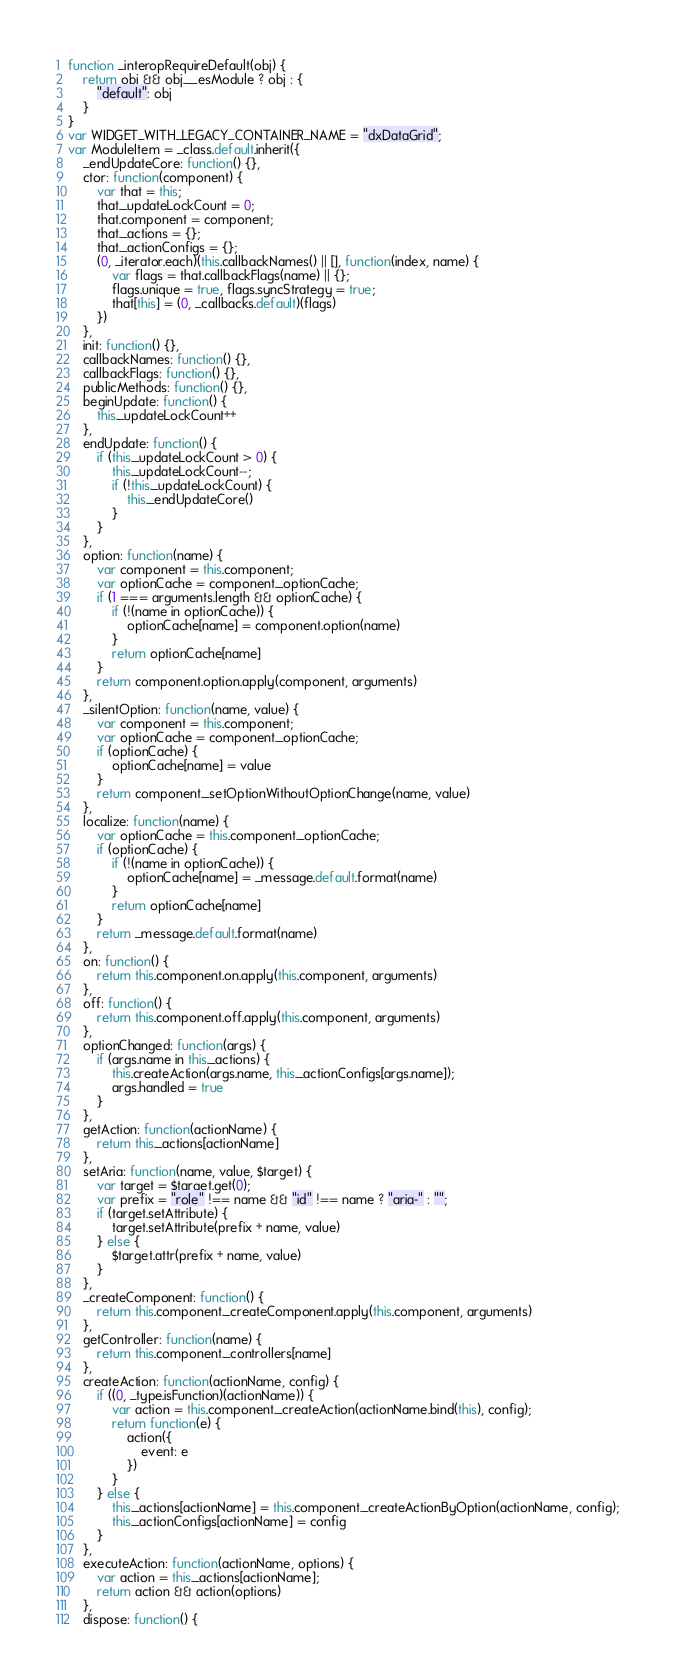Convert code to text. <code><loc_0><loc_0><loc_500><loc_500><_JavaScript_>function _interopRequireDefault(obj) {
    return obj && obj.__esModule ? obj : {
        "default": obj
    }
}
var WIDGET_WITH_LEGACY_CONTAINER_NAME = "dxDataGrid";
var ModuleItem = _class.default.inherit({
    _endUpdateCore: function() {},
    ctor: function(component) {
        var that = this;
        that._updateLockCount = 0;
        that.component = component;
        that._actions = {};
        that._actionConfigs = {};
        (0, _iterator.each)(this.callbackNames() || [], function(index, name) {
            var flags = that.callbackFlags(name) || {};
            flags.unique = true, flags.syncStrategy = true;
            that[this] = (0, _callbacks.default)(flags)
        })
    },
    init: function() {},
    callbackNames: function() {},
    callbackFlags: function() {},
    publicMethods: function() {},
    beginUpdate: function() {
        this._updateLockCount++
    },
    endUpdate: function() {
        if (this._updateLockCount > 0) {
            this._updateLockCount--;
            if (!this._updateLockCount) {
                this._endUpdateCore()
            }
        }
    },
    option: function(name) {
        var component = this.component;
        var optionCache = component._optionCache;
        if (1 === arguments.length && optionCache) {
            if (!(name in optionCache)) {
                optionCache[name] = component.option(name)
            }
            return optionCache[name]
        }
        return component.option.apply(component, arguments)
    },
    _silentOption: function(name, value) {
        var component = this.component;
        var optionCache = component._optionCache;
        if (optionCache) {
            optionCache[name] = value
        }
        return component._setOptionWithoutOptionChange(name, value)
    },
    localize: function(name) {
        var optionCache = this.component._optionCache;
        if (optionCache) {
            if (!(name in optionCache)) {
                optionCache[name] = _message.default.format(name)
            }
            return optionCache[name]
        }
        return _message.default.format(name)
    },
    on: function() {
        return this.component.on.apply(this.component, arguments)
    },
    off: function() {
        return this.component.off.apply(this.component, arguments)
    },
    optionChanged: function(args) {
        if (args.name in this._actions) {
            this.createAction(args.name, this._actionConfigs[args.name]);
            args.handled = true
        }
    },
    getAction: function(actionName) {
        return this._actions[actionName]
    },
    setAria: function(name, value, $target) {
        var target = $target.get(0);
        var prefix = "role" !== name && "id" !== name ? "aria-" : "";
        if (target.setAttribute) {
            target.setAttribute(prefix + name, value)
        } else {
            $target.attr(prefix + name, value)
        }
    },
    _createComponent: function() {
        return this.component._createComponent.apply(this.component, arguments)
    },
    getController: function(name) {
        return this.component._controllers[name]
    },
    createAction: function(actionName, config) {
        if ((0, _type.isFunction)(actionName)) {
            var action = this.component._createAction(actionName.bind(this), config);
            return function(e) {
                action({
                    event: e
                })
            }
        } else {
            this._actions[actionName] = this.component._createActionByOption(actionName, config);
            this._actionConfigs[actionName] = config
        }
    },
    executeAction: function(actionName, options) {
        var action = this._actions[actionName];
        return action && action(options)
    },
    dispose: function() {</code> 